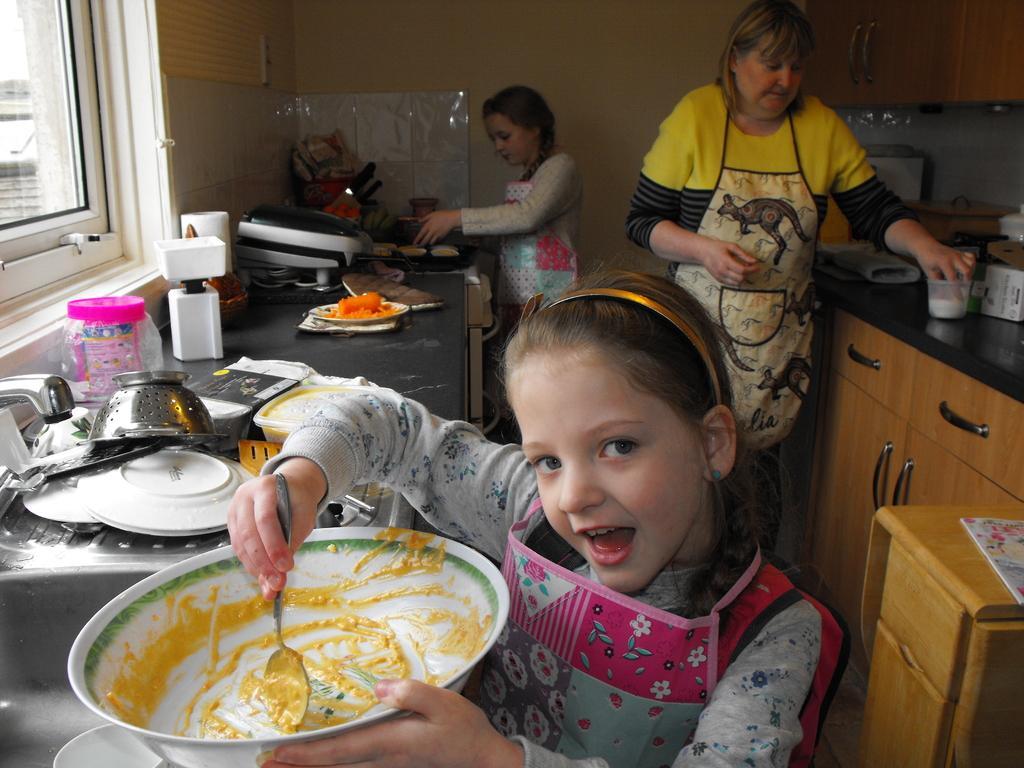Please provide a concise description of this image. In the center of the image we can see a kid is holding a bowl and a spoon. In the background there is a wall, window, kitchen platforms, drawers, utensils, one sink, one tap, one jar, some food items, two persons and a few other objects. 